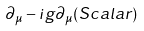Convert formula to latex. <formula><loc_0><loc_0><loc_500><loc_500>\partial _ { \mu } - i g \partial _ { \mu } ( S c a l a r )</formula> 